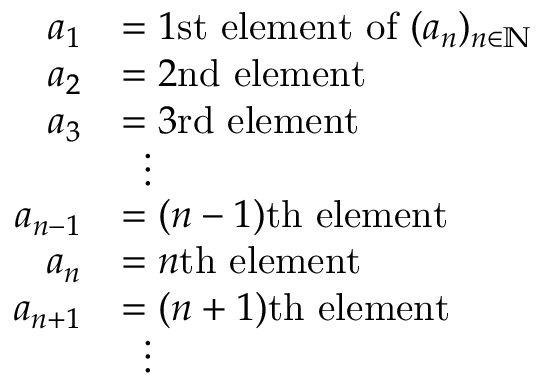<formula> <loc_0><loc_0><loc_500><loc_500>{ \begin{array} { r l } { a _ { 1 } } & { = 1 { s t e l e m e n t o f } ( a _ { n } ) _ { n \in \mathbb { N } } } \\ { a _ { 2 } } & { = 2 { n d e l e m e n t } } \\ { a _ { 3 } } & { = 3 { r d e l e m e n t } } \\ & { \, \vdots } \\ { a _ { n - 1 } } & { = ( n - 1 ) { t h e l e m e n t } } \\ { a _ { n } } & { = n { t h e l e m e n t } } \\ { a _ { n + 1 } } & { = ( n + 1 ) { t h e l e m e n t } } \\ & { \, \vdots } \end{array} }</formula> 